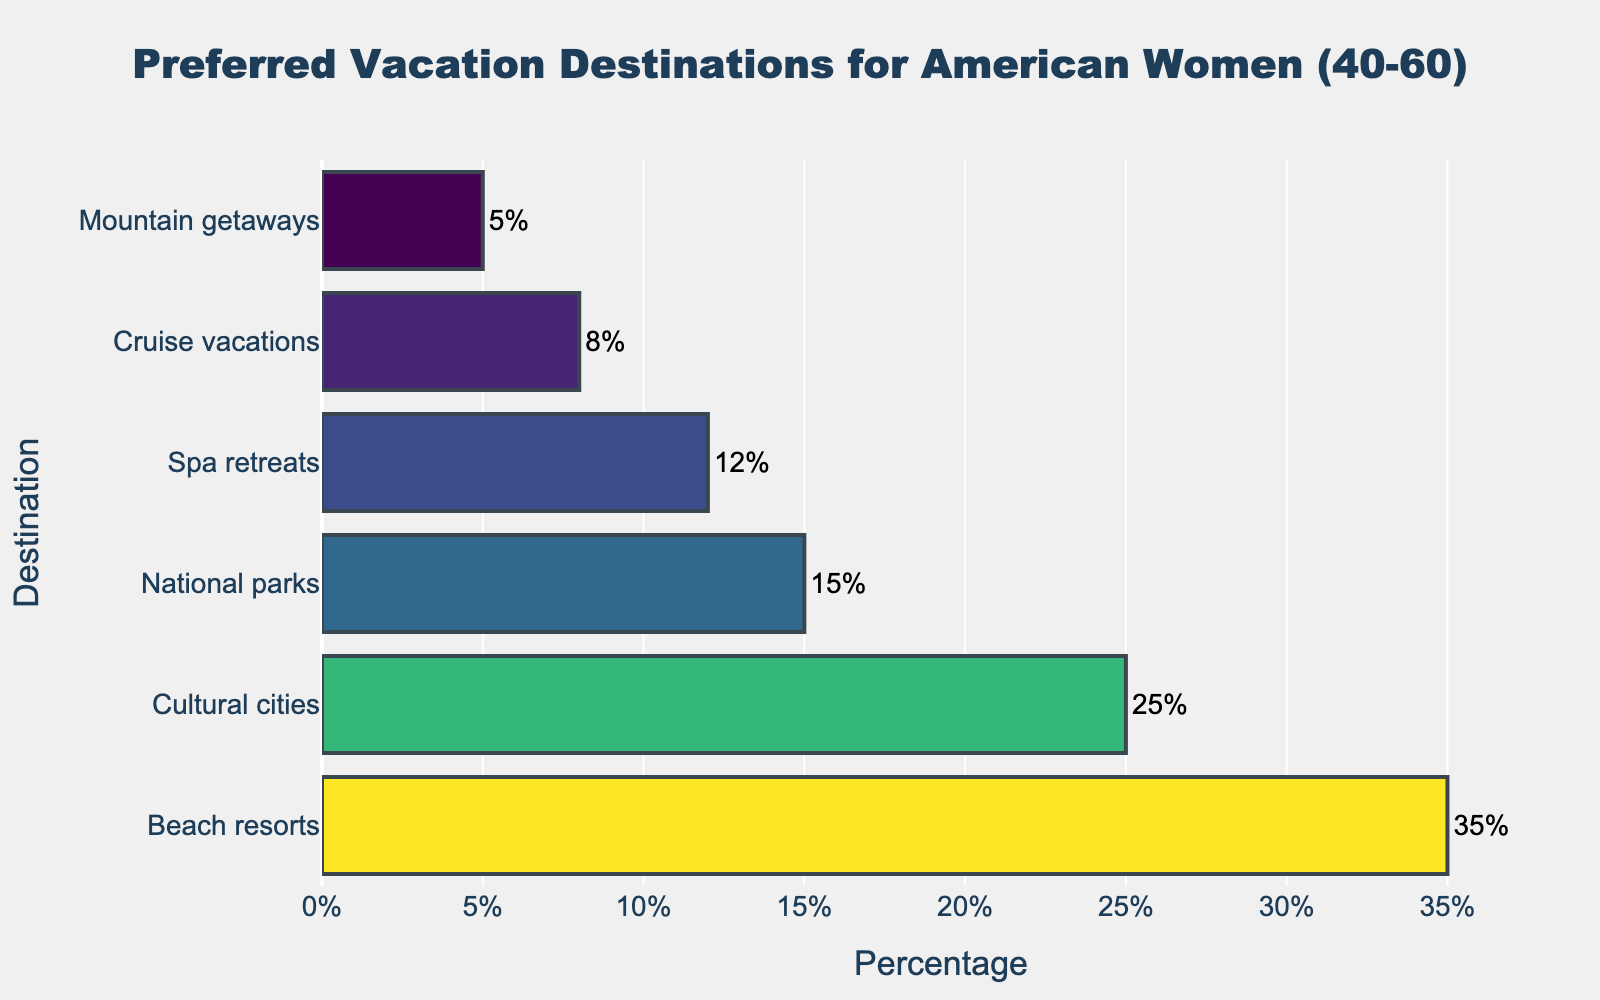What's the most preferred vacation destination for American women aged 40-60 according to the figure? We look at the bar with the highest percentage value. The longest bar represents the most preferred destination.
Answer: Beach resorts What is the combined percentage of women who prefer beach resorts and cultural cities? We sum the percentages of Beach resorts and Cultural cities. Beach resorts have 35% and Cultural cities have 25%, so the combined percentage is 35% + 25% = 60%.
Answer: 60% Which vacation destination is least preferred according to the figure? We identify the bar with the smallest percentage value. The shortest bar indicates the least preferred destination.
Answer: Mountain getaways How much more popular are beach resorts compared to spa retreats? We find the percentage difference between Beach resorts and Spa retreats. Beach resorts have 35%, and Spa retreats have 12%. The difference is 35% - 12% = 23%.
Answer: 23% Rank the vacation destinations from most preferred to least preferred according to the figure. We order the destinations based on their percentage values in descending order.
Answer: Beach resorts, Cultural cities, National parks, Spa retreats, Cruise vacations, Mountain getaways How many destinations have a preference percentage of less than 10%? We count the bars with percentages less than 10%. Cruise vacations and Mountain getaways are the ones below 10%.
Answer: 2 What is the average percentage preference for the listed vacation destinations? We calculate the average by summing all percentages (35 + 25 + 15 + 12 + 8 + 5 = 100) and dividing by the number of destinations (6). So, the average is 100 / 6 ≈ 16.67%.
Answer: 16.67% Are there more women who prefer National parks or Spa retreats? We compare the percentages of National parks (15%) and Spa retreats (12%). National parks have a higher percentage.
Answer: National parks What percentage of women prefer destinations other than beach resorts? We subtract the percentage for Beach resorts from 100% to find the total percentage for all other destinations. 100% - 35% = 65%.
Answer: 65% What's the difference between the combined percentage of National parks and Mountain getaways compared to Cruise vacations? We first find the combined percentage of National parks (15%) and Mountain getaways (5%), which is 15% + 5% = 20%. Then, we calculate the difference with Cruise vacations (8%). 20% - 8% = 12%.
Answer: 12% 